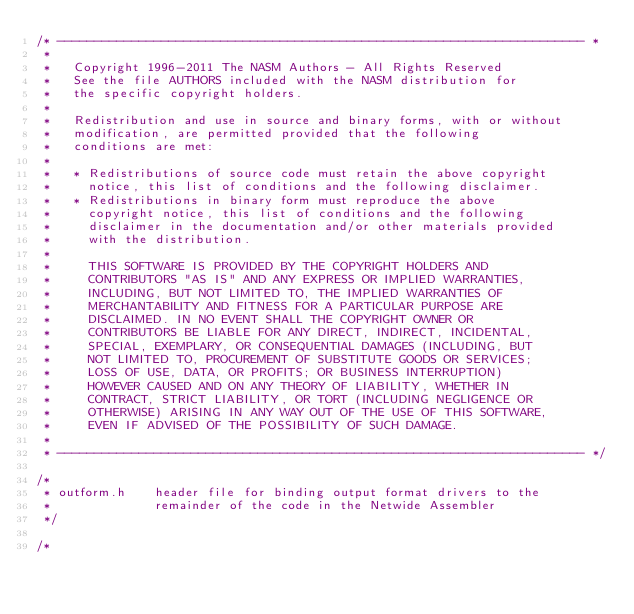Convert code to text. <code><loc_0><loc_0><loc_500><loc_500><_C_>/* ----------------------------------------------------------------------- *
 *
 *   Copyright 1996-2011 The NASM Authors - All Rights Reserved
 *   See the file AUTHORS included with the NASM distribution for
 *   the specific copyright holders.
 *
 *   Redistribution and use in source and binary forms, with or without
 *   modification, are permitted provided that the following
 *   conditions are met:
 *
 *   * Redistributions of source code must retain the above copyright
 *     notice, this list of conditions and the following disclaimer.
 *   * Redistributions in binary form must reproduce the above
 *     copyright notice, this list of conditions and the following
 *     disclaimer in the documentation and/or other materials provided
 *     with the distribution.
 *
 *     THIS SOFTWARE IS PROVIDED BY THE COPYRIGHT HOLDERS AND
 *     CONTRIBUTORS "AS IS" AND ANY EXPRESS OR IMPLIED WARRANTIES,
 *     INCLUDING, BUT NOT LIMITED TO, THE IMPLIED WARRANTIES OF
 *     MERCHANTABILITY AND FITNESS FOR A PARTICULAR PURPOSE ARE
 *     DISCLAIMED. IN NO EVENT SHALL THE COPYRIGHT OWNER OR
 *     CONTRIBUTORS BE LIABLE FOR ANY DIRECT, INDIRECT, INCIDENTAL,
 *     SPECIAL, EXEMPLARY, OR CONSEQUENTIAL DAMAGES (INCLUDING, BUT
 *     NOT LIMITED TO, PROCUREMENT OF SUBSTITUTE GOODS OR SERVICES;
 *     LOSS OF USE, DATA, OR PROFITS; OR BUSINESS INTERRUPTION)
 *     HOWEVER CAUSED AND ON ANY THEORY OF LIABILITY, WHETHER IN
 *     CONTRACT, STRICT LIABILITY, OR TORT (INCLUDING NEGLIGENCE OR
 *     OTHERWISE) ARISING IN ANY WAY OUT OF THE USE OF THIS SOFTWARE,
 *     EVEN IF ADVISED OF THE POSSIBILITY OF SUCH DAMAGE.
 *
 * ----------------------------------------------------------------------- */

/*
 * outform.h    header file for binding output format drivers to the
 *              remainder of the code in the Netwide Assembler
 */

/*</code> 